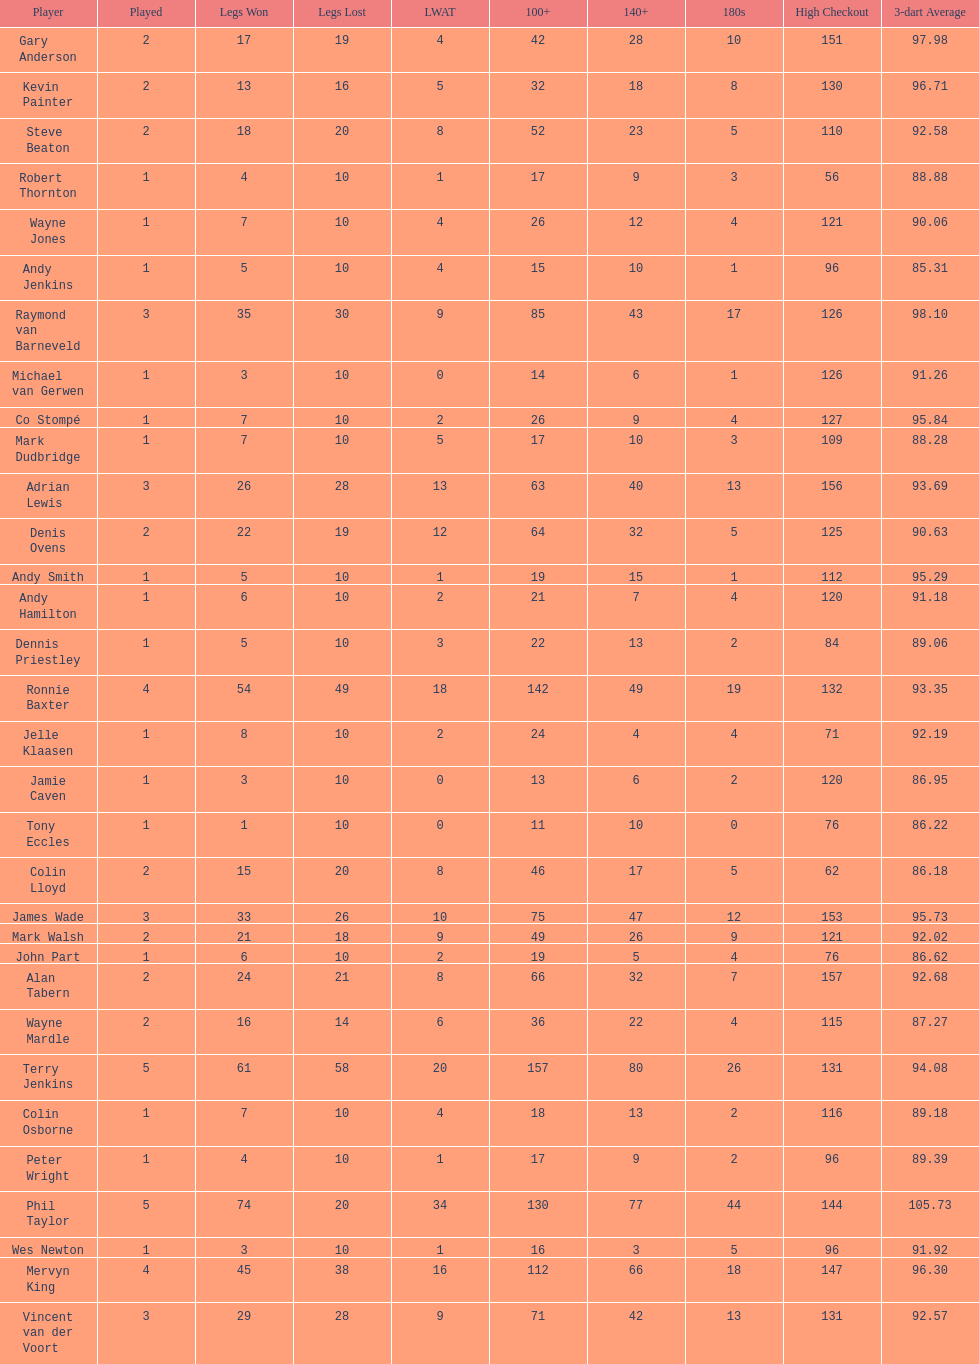Help me parse the entirety of this table. {'header': ['Player', 'Played', 'Legs Won', 'Legs Lost', 'LWAT', '100+', '140+', '180s', 'High Checkout', '3-dart Average'], 'rows': [['Gary Anderson', '2', '17', '19', '4', '42', '28', '10', '151', '97.98'], ['Kevin Painter', '2', '13', '16', '5', '32', '18', '8', '130', '96.71'], ['Steve Beaton', '2', '18', '20', '8', '52', '23', '5', '110', '92.58'], ['Robert Thornton', '1', '4', '10', '1', '17', '9', '3', '56', '88.88'], ['Wayne Jones', '1', '7', '10', '4', '26', '12', '4', '121', '90.06'], ['Andy Jenkins', '1', '5', '10', '4', '15', '10', '1', '96', '85.31'], ['Raymond van Barneveld', '3', '35', '30', '9', '85', '43', '17', '126', '98.10'], ['Michael van Gerwen', '1', '3', '10', '0', '14', '6', '1', '126', '91.26'], ['Co Stompé', '1', '7', '10', '2', '26', '9', '4', '127', '95.84'], ['Mark Dudbridge', '1', '7', '10', '5', '17', '10', '3', '109', '88.28'], ['Adrian Lewis', '3', '26', '28', '13', '63', '40', '13', '156', '93.69'], ['Denis Ovens', '2', '22', '19', '12', '64', '32', '5', '125', '90.63'], ['Andy Smith', '1', '5', '10', '1', '19', '15', '1', '112', '95.29'], ['Andy Hamilton', '1', '6', '10', '2', '21', '7', '4', '120', '91.18'], ['Dennis Priestley', '1', '5', '10', '3', '22', '13', '2', '84', '89.06'], ['Ronnie Baxter', '4', '54', '49', '18', '142', '49', '19', '132', '93.35'], ['Jelle Klaasen', '1', '8', '10', '2', '24', '4', '4', '71', '92.19'], ['Jamie Caven', '1', '3', '10', '0', '13', '6', '2', '120', '86.95'], ['Tony Eccles', '1', '1', '10', '0', '11', '10', '0', '76', '86.22'], ['Colin Lloyd', '2', '15', '20', '8', '46', '17', '5', '62', '86.18'], ['James Wade', '3', '33', '26', '10', '75', '47', '12', '153', '95.73'], ['Mark Walsh', '2', '21', '18', '9', '49', '26', '9', '121', '92.02'], ['John Part', '1', '6', '10', '2', '19', '5', '4', '76', '86.62'], ['Alan Tabern', '2', '24', '21', '8', '66', '32', '7', '157', '92.68'], ['Wayne Mardle', '2', '16', '14', '6', '36', '22', '4', '115', '87.27'], ['Terry Jenkins', '5', '61', '58', '20', '157', '80', '26', '131', '94.08'], ['Colin Osborne', '1', '7', '10', '4', '18', '13', '2', '116', '89.18'], ['Peter Wright', '1', '4', '10', '1', '17', '9', '2', '96', '89.39'], ['Phil Taylor', '5', '74', '20', '34', '130', '77', '44', '144', '105.73'], ['Wes Newton', '1', '3', '10', '1', '16', '3', '5', '96', '91.92'], ['Mervyn King', '4', '45', '38', '16', '112', '66', '18', '147', '96.30'], ['Vincent van der Voort', '3', '29', '28', '9', '71', '42', '13', '131', '92.57']]} List each of the players with a high checkout of 131. Terry Jenkins, Vincent van der Voort. 